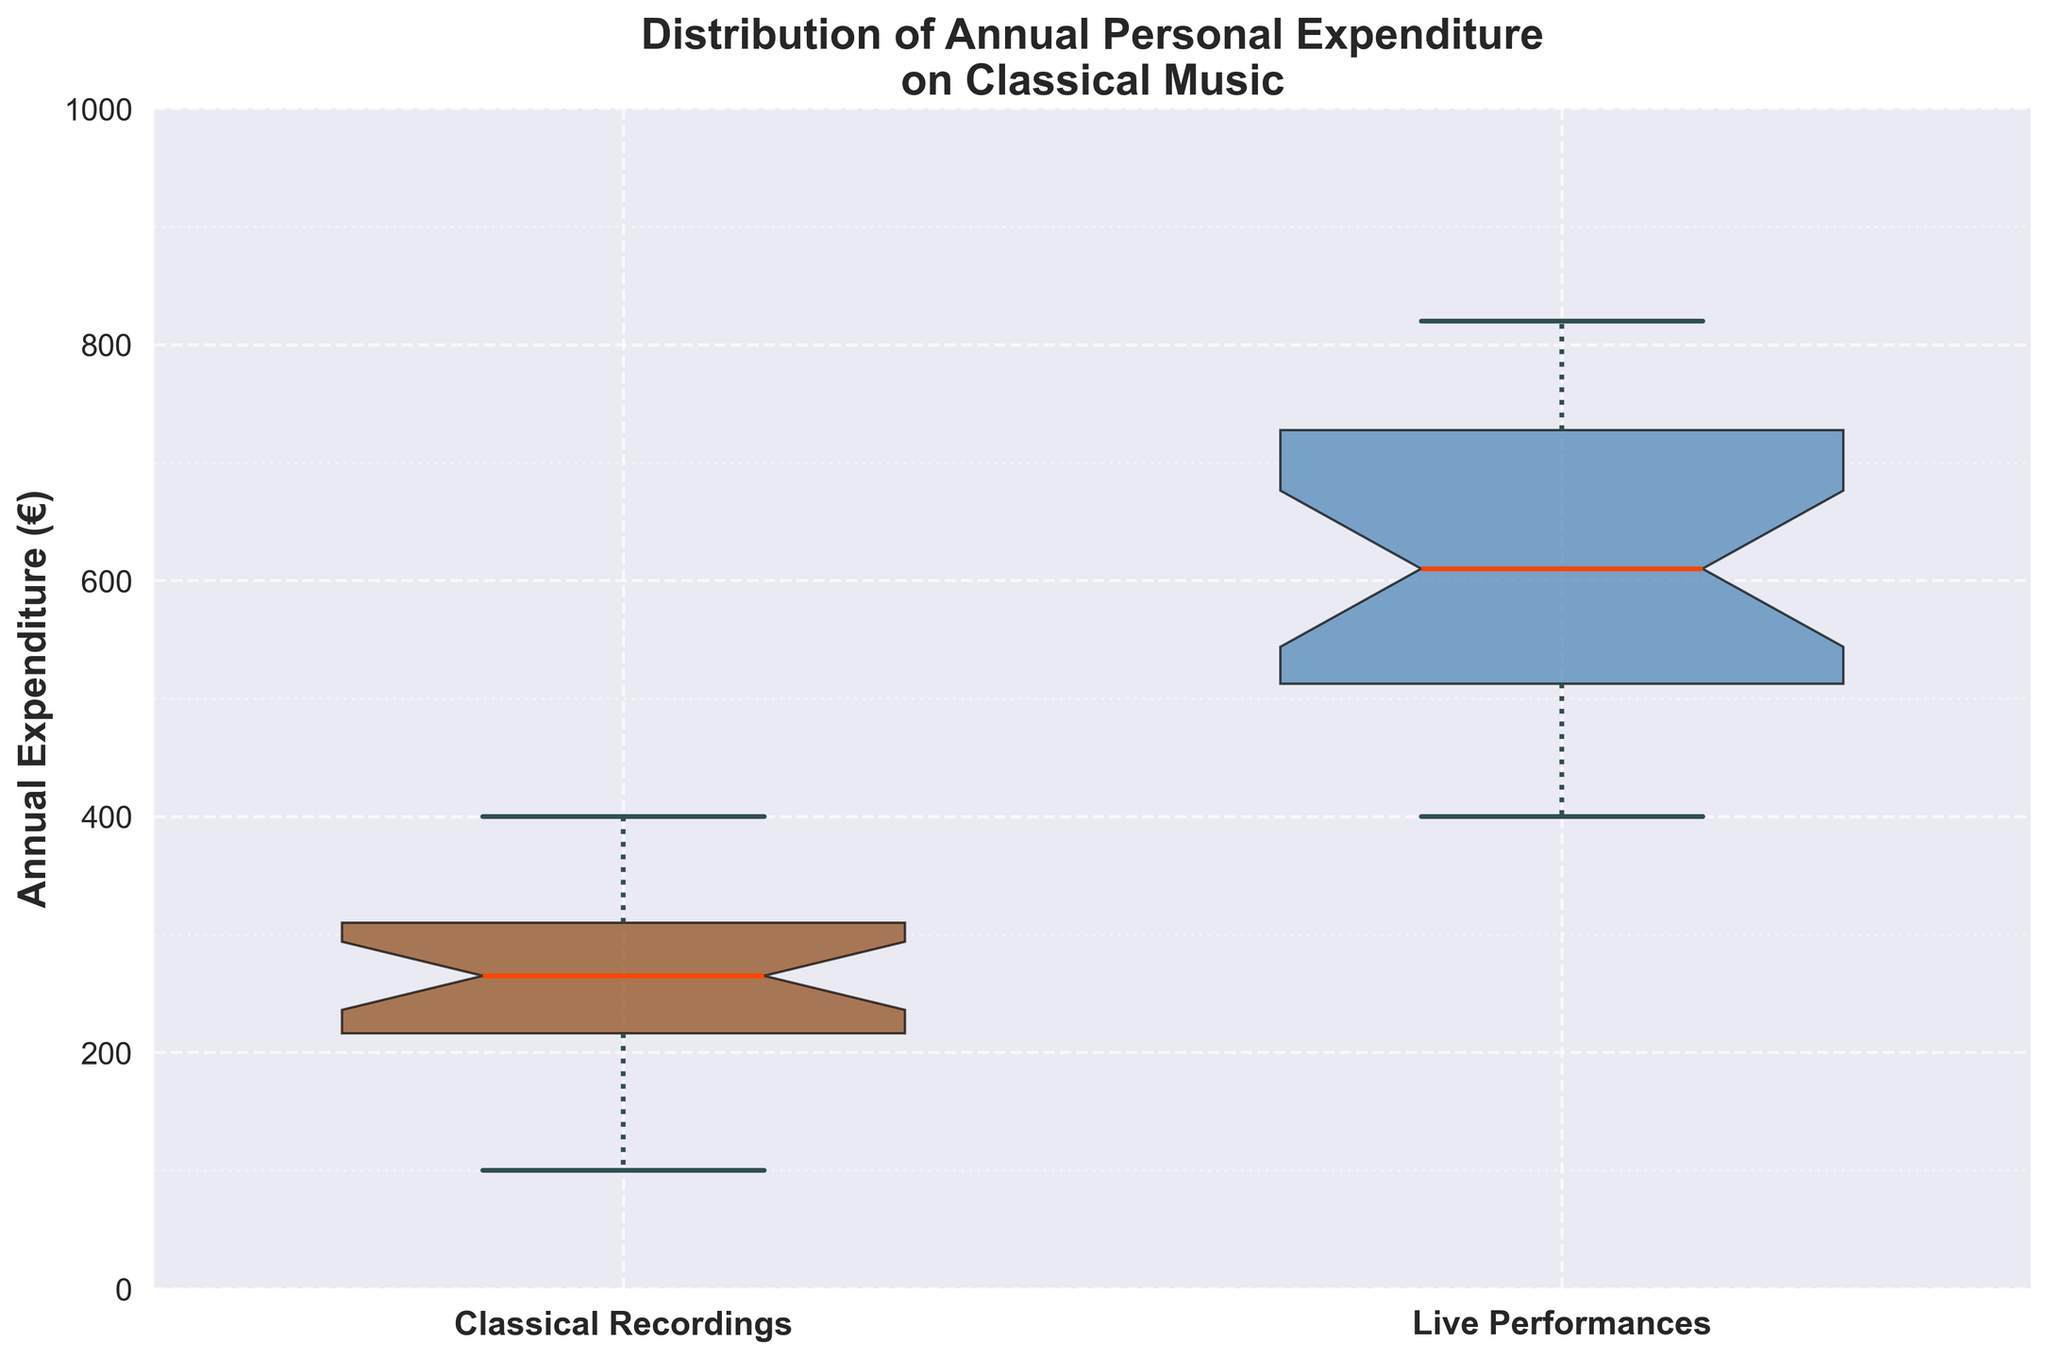What is the title of the plot? The title is at the top of the plot and provides an overview of the data being displayed.
Answer: Distribution of Annual Personal Expenditure on Classical Music What are the two categories shown on the x-axis? The x-axis labels identify the categories being compared in the box plot.
Answer: Classical Recordings and Live Performances Which category has a higher median annual expenditure? The median is indicated by the horizontal line within the box. Compare the median positions of both categories.
Answer: Live Performances What is the approximate range of annual expenditure on classical recordings? The range can be identified by looking at the bottom and top whiskers of the box plot for classical recordings.
Answer: 100 - 400 euros Which category has more variability in expenditure? Variability can be assessed by the height of the boxes and the length of the whiskers. Compare the lengths between the two categories.
Answer: Live Performances Which category has the highest recorded value for annual expenditure? The highest value is represented by the top of the upper whisker or any outliers above it. Identify this in both categories.
Answer: Live Performances Is the interquartile range (IQR) larger for classical recordings or live performances? The IQR is represented by the length of the box itself. Compare the lengths of the boxes between the two categories.
Answer: Live Performances Are there any outliers in the expenditure for classical recordings? Outliers are represented by individual points outside the whiskers. Check if there are such points in the classical recordings box plot.
Answer: No What is the approximate median annual expenditure on live performances? The median is the horizontal line inside the box. For live performances, locate this line and identify the value.
Answer: Around 650 euros Does either category have a lower minimum value of expenditure? Compare the bottom whiskers of both box plots to identify which category has the lower minimum value.
Answer: Classical Recordings 